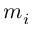Convert formula to latex. <formula><loc_0><loc_0><loc_500><loc_500>m _ { i }</formula> 